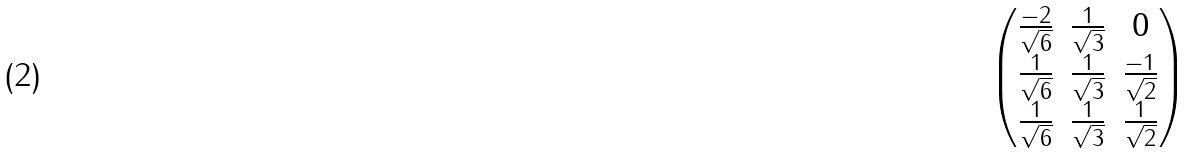Convert formula to latex. <formula><loc_0><loc_0><loc_500><loc_500>\begin{pmatrix} \frac { - 2 } { \sqrt { 6 } } & \frac { 1 } { \sqrt { 3 } } & 0 \\ \frac { 1 } { \sqrt { 6 } } & \frac { 1 } { \sqrt { 3 } } & \frac { - 1 } { \sqrt { 2 } } \\ \frac { 1 } { \sqrt { 6 } } & \frac { 1 } { \sqrt { 3 } } & \frac { 1 } { \sqrt { 2 } } \\ \end{pmatrix}</formula> 